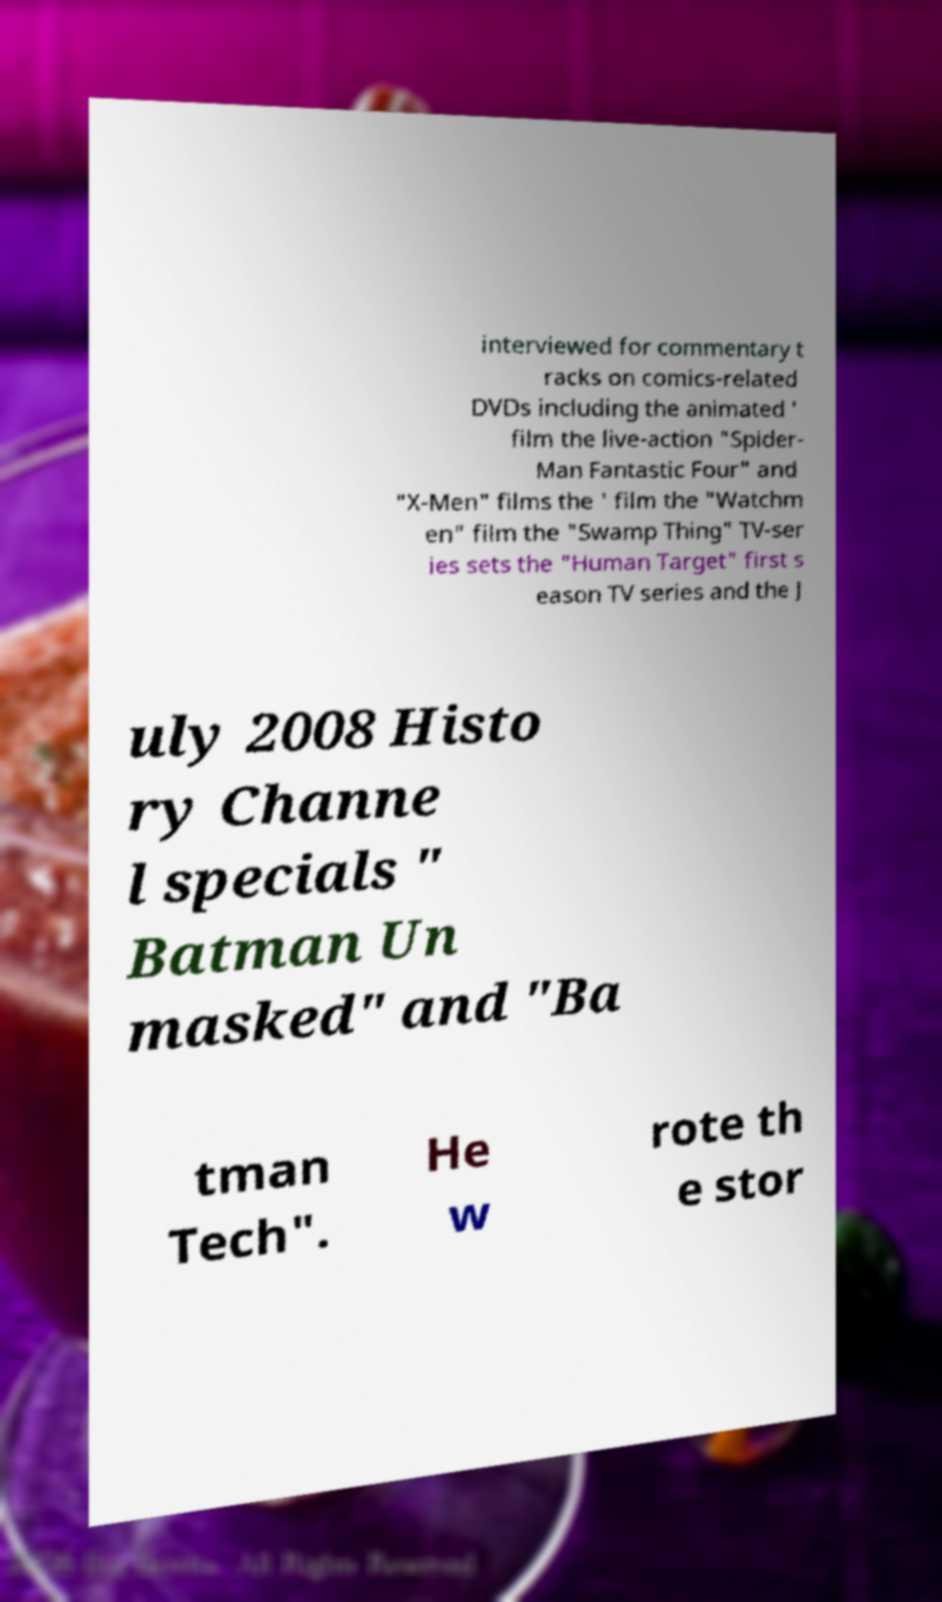Can you accurately transcribe the text from the provided image for me? interviewed for commentary t racks on comics-related DVDs including the animated ' film the live-action "Spider- Man Fantastic Four" and "X-Men" films the ' film the "Watchm en" film the "Swamp Thing" TV-ser ies sets the "Human Target" first s eason TV series and the J uly 2008 Histo ry Channe l specials " Batman Un masked" and "Ba tman Tech". He w rote th e stor 